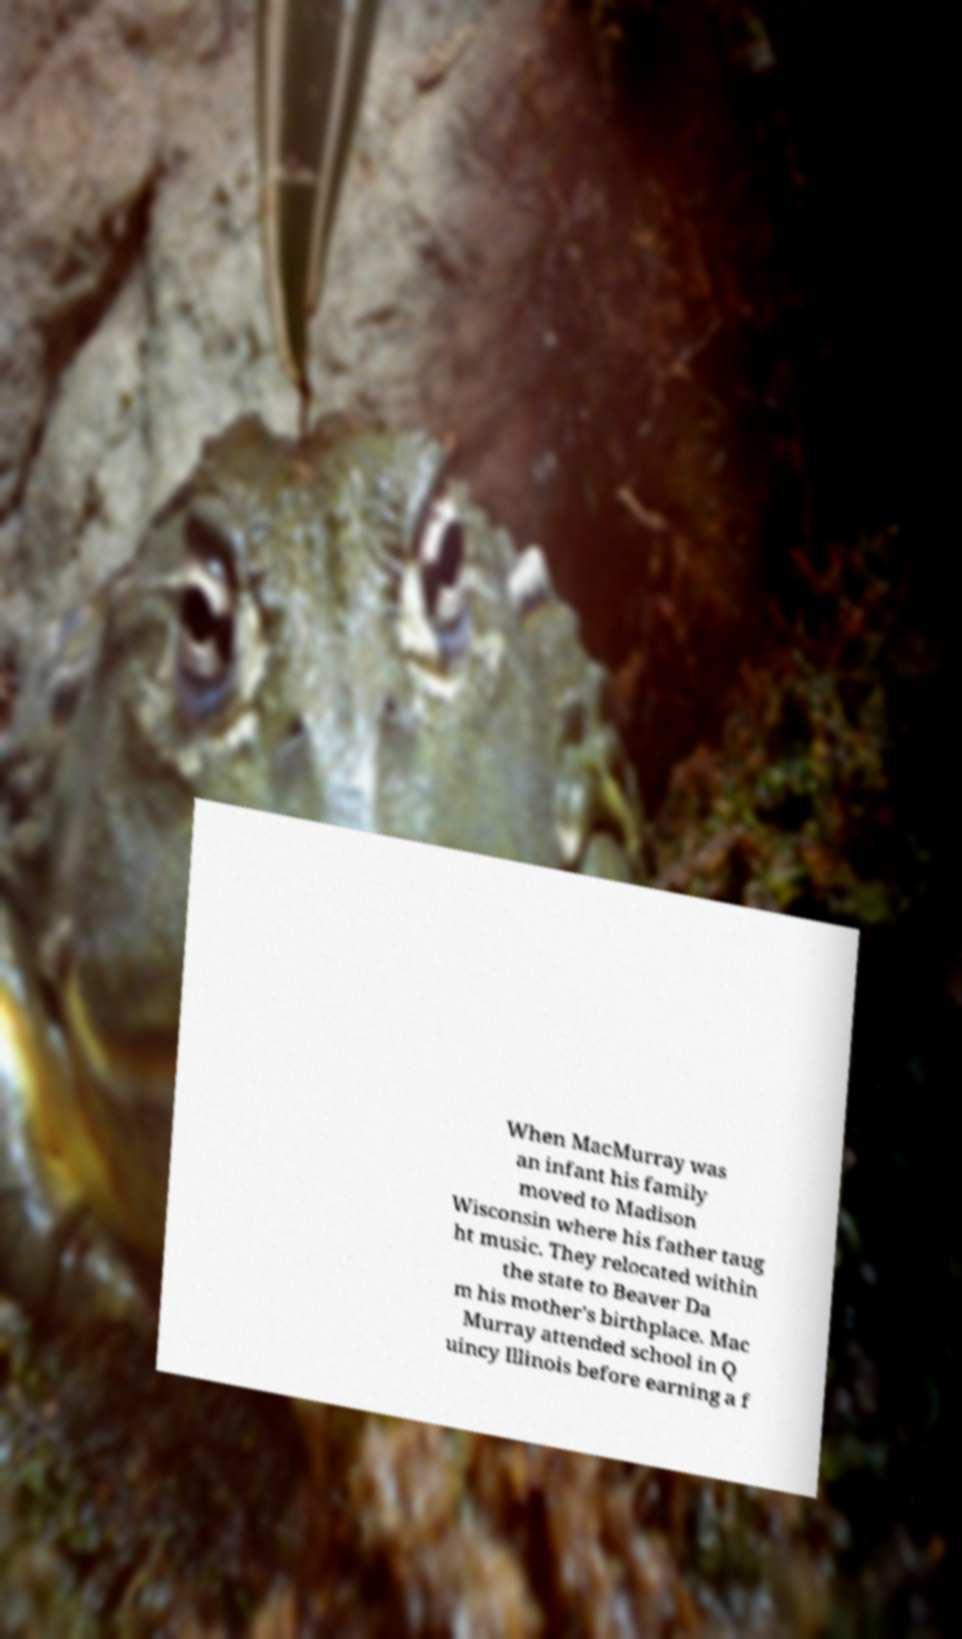For documentation purposes, I need the text within this image transcribed. Could you provide that? When MacMurray was an infant his family moved to Madison Wisconsin where his father taug ht music. They relocated within the state to Beaver Da m his mother's birthplace. Mac Murray attended school in Q uincy Illinois before earning a f 